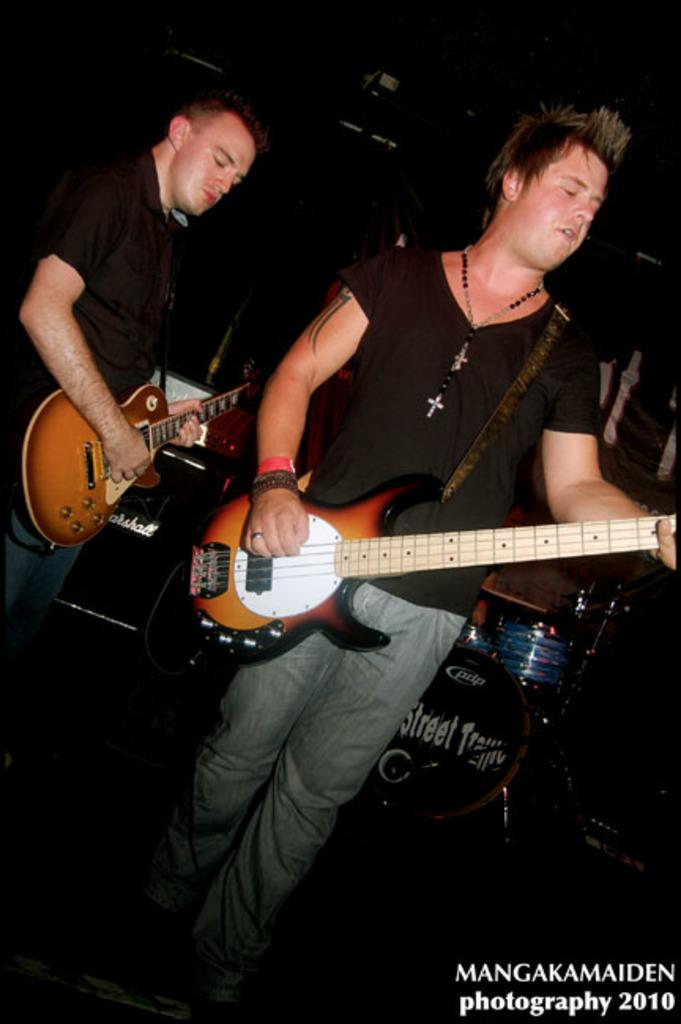How many people are in the image? There are two people in the image. What are the people holding in the image? Both people are holding guitars. What type of produce is being played by the people in the image? There is no produce present in the image; the people are holding guitars. Can you tell me how many thumbs are visible on the people's hands in the image? The number of visible thumbs cannot be determined from the image, as hands are not clearly visible. 